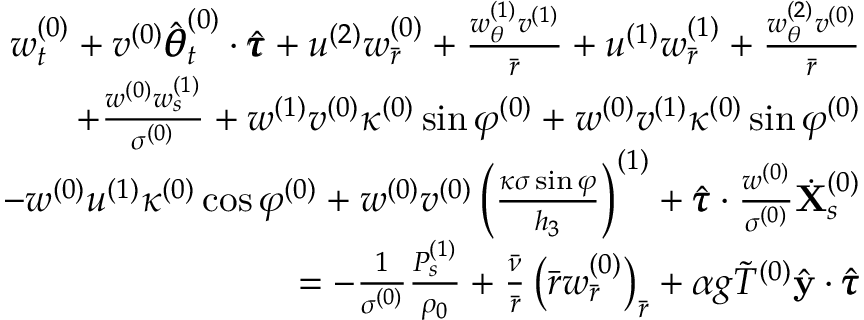Convert formula to latex. <formula><loc_0><loc_0><loc_500><loc_500>\begin{array} { r } { w _ { t } ^ { ( 0 ) } + v ^ { ( 0 ) } \hat { \pm b { \theta } } _ { t } ^ { ( 0 ) } \cdot \hat { \pm b { \tau } } + u ^ { ( 2 ) } w _ { \bar { r } } ^ { ( 0 ) } + \frac { w _ { \theta } ^ { ( 1 ) } v ^ { ( 1 ) } } { \bar { r } } + u ^ { ( 1 ) } w _ { \bar { r } } ^ { ( 1 ) } + \frac { w _ { \theta } ^ { ( 2 ) } v ^ { ( 0 ) } } { \bar { r } } } \\ { + \frac { w ^ { ( 0 ) } w _ { s } ^ { ( 1 ) } } { \sigma ^ { ( 0 ) } } + w ^ { ( 1 ) } v ^ { ( 0 ) } \kappa ^ { ( 0 ) } \sin \varphi ^ { ( 0 ) } + w ^ { ( 0 ) } v ^ { ( 1 ) } \kappa ^ { ( 0 ) } \sin \varphi ^ { ( 0 ) } } \\ { - w ^ { ( 0 ) } u ^ { ( 1 ) } \kappa ^ { ( 0 ) } \cos \varphi ^ { ( 0 ) } + w ^ { ( 0 ) } v ^ { ( 0 ) } \left ( \frac { \kappa \sigma \sin \varphi } { h _ { 3 } } \right ) ^ { ( 1 ) } + \hat { \pm b { \tau } } \cdot \frac { w ^ { ( 0 ) } } { \sigma ^ { ( 0 ) } } \dot { X } _ { s } ^ { ( 0 ) } } \\ { = - \frac { 1 } { \sigma ^ { ( 0 ) } } \frac { P _ { s } ^ { ( 1 ) } } { \rho _ { 0 } } + \frac { \bar { \nu } } { \bar { r } } \left ( \bar { r } w _ { \bar { r } } ^ { ( 0 ) } \right ) _ { \bar { r } } + \alpha g \tilde { T } ^ { ( 0 ) } \hat { y } \cdot \hat { \pm b { \tau } } } \end{array}</formula> 